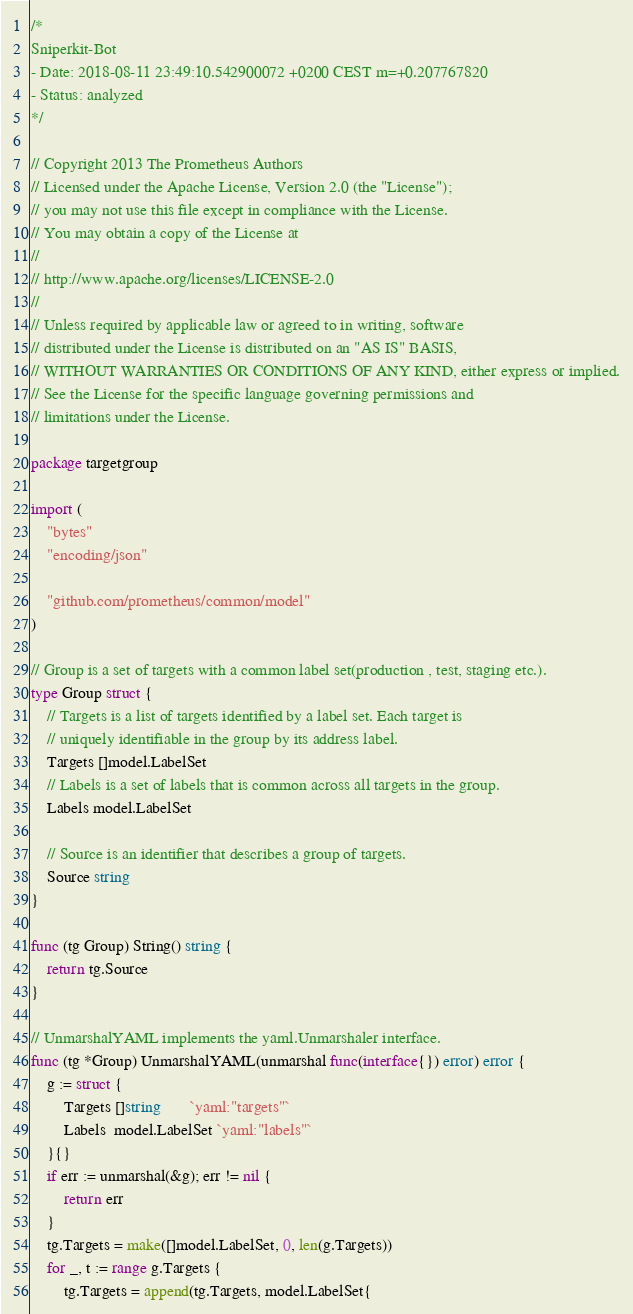Convert code to text. <code><loc_0><loc_0><loc_500><loc_500><_Go_>/*
Sniperkit-Bot
- Date: 2018-08-11 23:49:10.542900072 +0200 CEST m=+0.207767820
- Status: analyzed
*/

// Copyright 2013 The Prometheus Authors
// Licensed under the Apache License, Version 2.0 (the "License");
// you may not use this file except in compliance with the License.
// You may obtain a copy of the License at
//
// http://www.apache.org/licenses/LICENSE-2.0
//
// Unless required by applicable law or agreed to in writing, software
// distributed under the License is distributed on an "AS IS" BASIS,
// WITHOUT WARRANTIES OR CONDITIONS OF ANY KIND, either express or implied.
// See the License for the specific language governing permissions and
// limitations under the License.

package targetgroup

import (
	"bytes"
	"encoding/json"

	"github.com/prometheus/common/model"
)

// Group is a set of targets with a common label set(production , test, staging etc.).
type Group struct {
	// Targets is a list of targets identified by a label set. Each target is
	// uniquely identifiable in the group by its address label.
	Targets []model.LabelSet
	// Labels is a set of labels that is common across all targets in the group.
	Labels model.LabelSet

	// Source is an identifier that describes a group of targets.
	Source string
}

func (tg Group) String() string {
	return tg.Source
}

// UnmarshalYAML implements the yaml.Unmarshaler interface.
func (tg *Group) UnmarshalYAML(unmarshal func(interface{}) error) error {
	g := struct {
		Targets []string       `yaml:"targets"`
		Labels  model.LabelSet `yaml:"labels"`
	}{}
	if err := unmarshal(&g); err != nil {
		return err
	}
	tg.Targets = make([]model.LabelSet, 0, len(g.Targets))
	for _, t := range g.Targets {
		tg.Targets = append(tg.Targets, model.LabelSet{</code> 